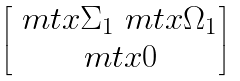Convert formula to latex. <formula><loc_0><loc_0><loc_500><loc_500>\begin{bmatrix} \ m t x { \Sigma } _ { 1 } \ m t x { \Omega } _ { 1 } \\ \ m t x { 0 } \end{bmatrix}</formula> 